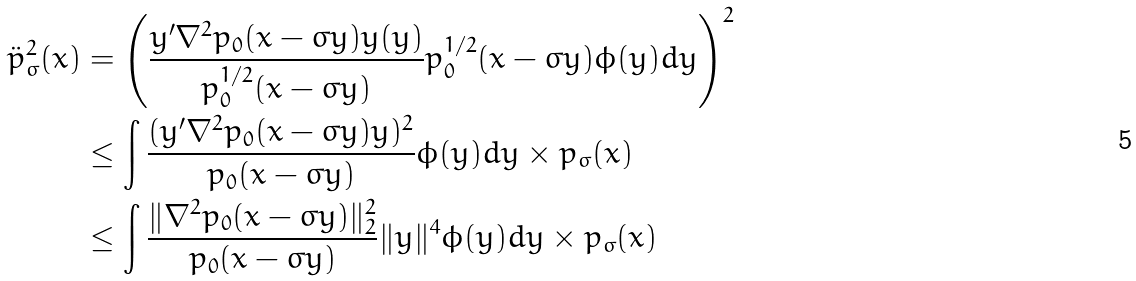<formula> <loc_0><loc_0><loc_500><loc_500>\ddot { p } _ { \sigma } ^ { 2 } ( x ) & = \left ( \frac { y ^ { \prime } \nabla ^ { 2 } p _ { 0 } ( x - \sigma y ) y ( y ) } { p _ { 0 } ^ { 1 / 2 } ( x - \sigma y ) } p _ { 0 } ^ { 1 / 2 } ( x - \sigma y ) \phi ( y ) d y \right ) ^ { 2 } \\ & \leq \int \frac { ( y ^ { \prime } \nabla ^ { 2 } p _ { 0 } ( x - \sigma y ) y ) ^ { 2 } } { p _ { 0 } ( x - \sigma y ) } \phi ( y ) d y \times p _ { \sigma } ( x ) \\ & \leq \int \frac { \| \nabla ^ { 2 } p _ { 0 } ( x - \sigma y ) \| _ { 2 } ^ { 2 } } { p _ { 0 } ( x - \sigma y ) } \| y \| ^ { 4 } \phi ( y ) d y \times p _ { \sigma } ( x )</formula> 